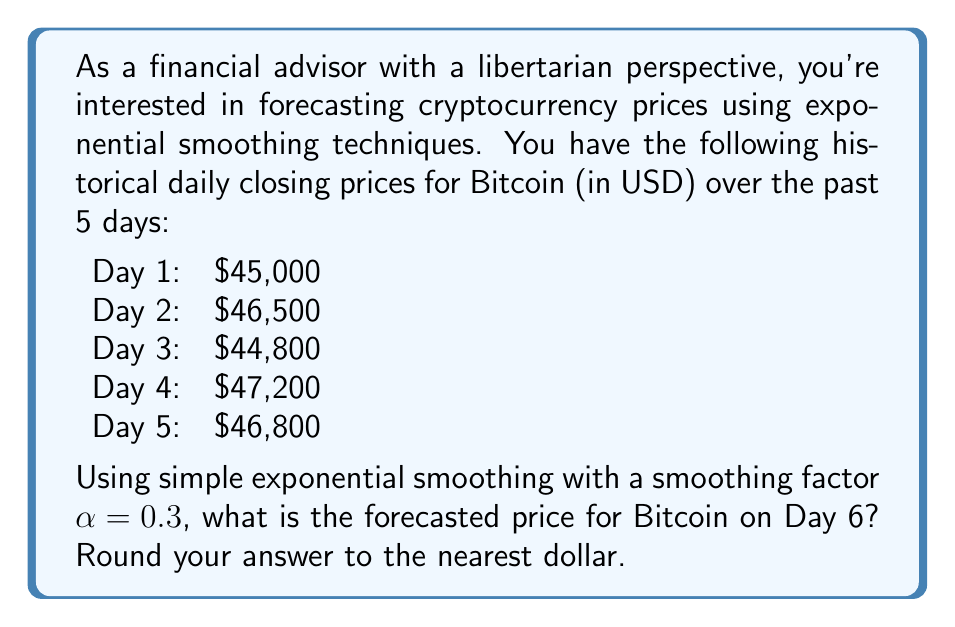What is the answer to this math problem? To forecast the cryptocurrency price using simple exponential smoothing, we'll follow these steps:

1) The formula for simple exponential smoothing is:

   $$F_{t+1} = \alpha Y_t + (1-\alpha)F_t$$

   Where:
   $F_{t+1}$ is the forecast for the next period
   $\alpha$ is the smoothing factor (0.3 in this case)
   $Y_t$ is the actual value at time t
   $F_t$ is the forecast for the current period

2) We start by setting $F_1 = Y_1 = 45,000$ (the first actual value)

3) Now we calculate the forecasts for each day:

   For Day 2:
   $$F_2 = 0.3(45,000) + 0.7(45,000) = 45,000$$

   For Day 3:
   $$F_3 = 0.3(46,500) + 0.7(45,000) = 45,450$$

   For Day 4:
   $$F_4 = 0.3(44,800) + 0.7(45,450) = 45,255$$

   For Day 5:
   $$F_5 = 0.3(47,200) + 0.7(45,255) = 45,838.5$$

4) Finally, we can calculate the forecast for Day 6:

   $$F_6 = 0.3(46,800) + 0.7(45,838.5) = 46,126.95$$

5) Rounding to the nearest dollar gives us $46,127.

This method allows for quick adaptation to price changes while smoothing out short-term fluctuations, which aligns with the libertarian view of minimal intervention and letting the market guide prices.
Answer: $46,127 